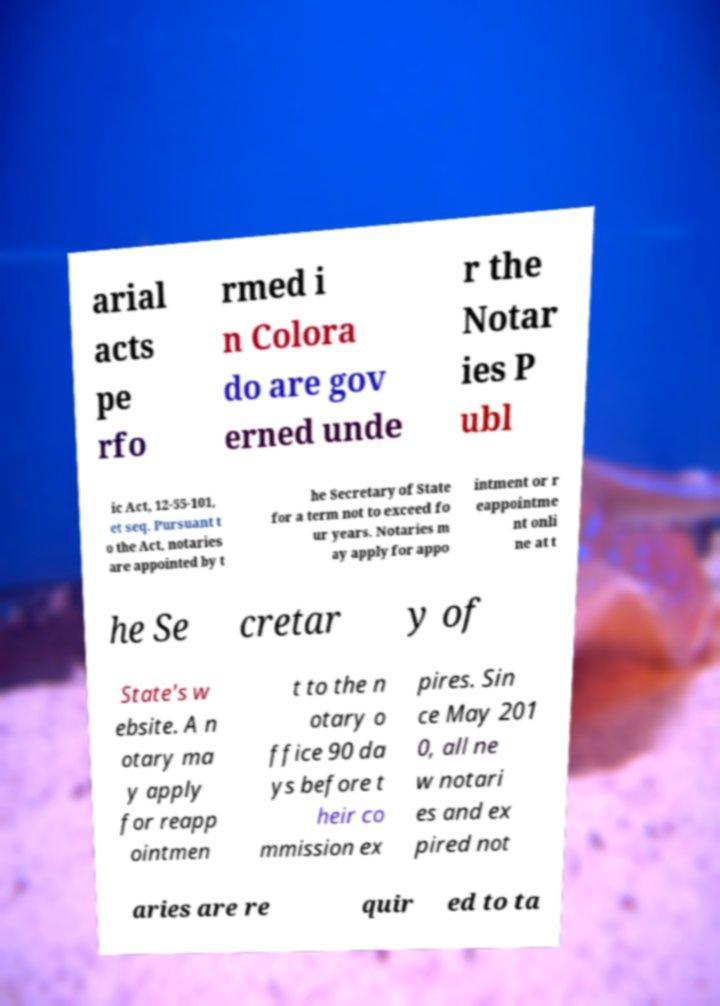Could you assist in decoding the text presented in this image and type it out clearly? arial acts pe rfo rmed i n Colora do are gov erned unde r the Notar ies P ubl ic Act, 12-55-101, et seq. Pursuant t o the Act, notaries are appointed by t he Secretary of State for a term not to exceed fo ur years. Notaries m ay apply for appo intment or r eappointme nt onli ne at t he Se cretar y of State's w ebsite. A n otary ma y apply for reapp ointmen t to the n otary o ffice 90 da ys before t heir co mmission ex pires. Sin ce May 201 0, all ne w notari es and ex pired not aries are re quir ed to ta 